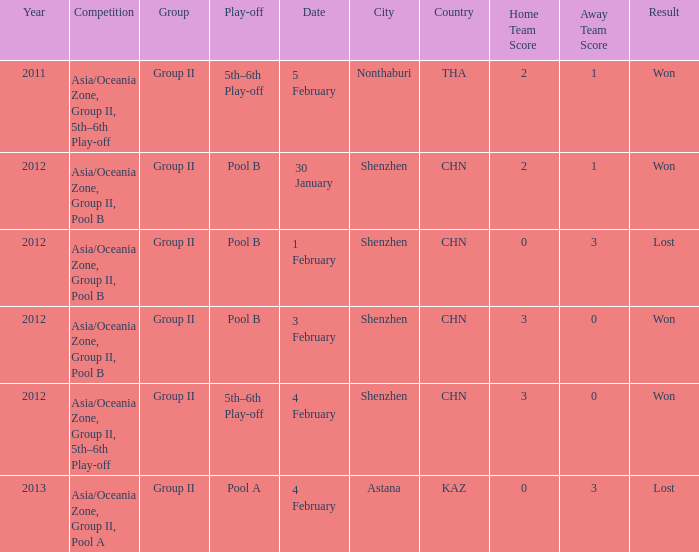What is the sum of the year for 5 february? 2011.0. 